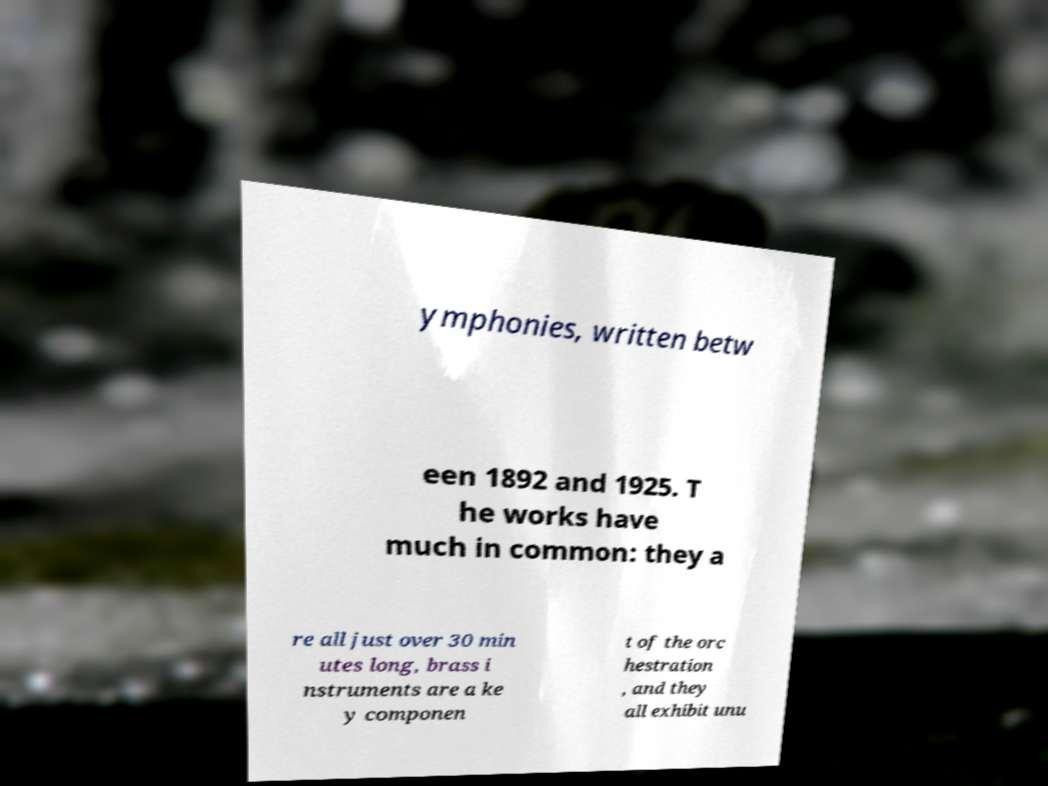There's text embedded in this image that I need extracted. Can you transcribe it verbatim? ymphonies, written betw een 1892 and 1925. T he works have much in common: they a re all just over 30 min utes long, brass i nstruments are a ke y componen t of the orc hestration , and they all exhibit unu 